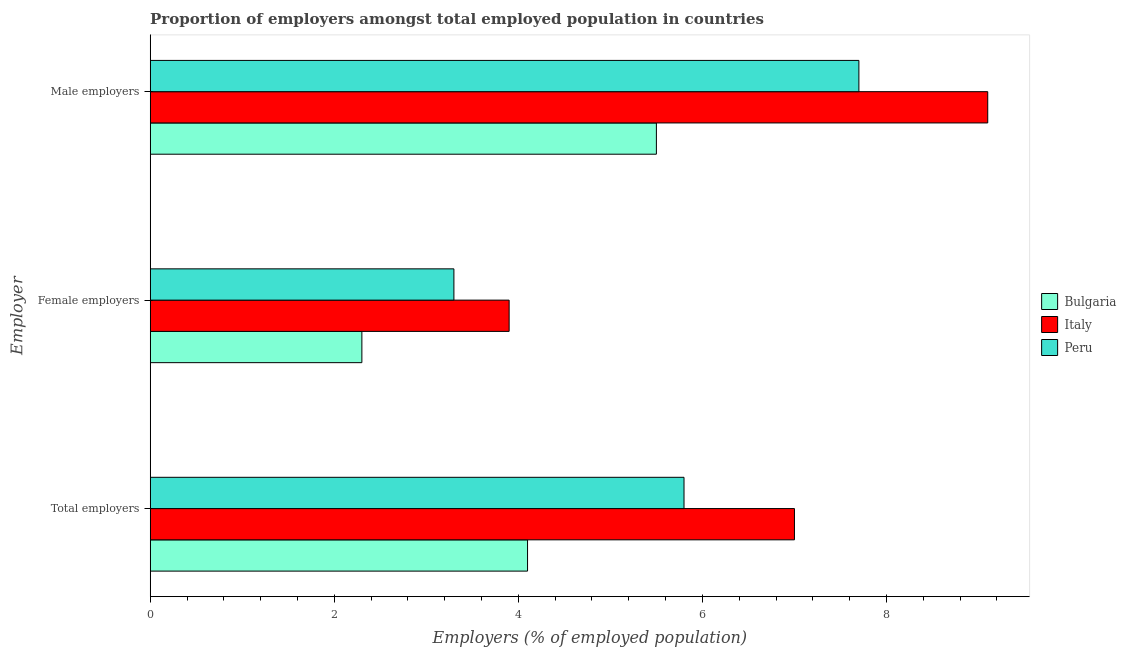Are the number of bars per tick equal to the number of legend labels?
Provide a short and direct response. Yes. Are the number of bars on each tick of the Y-axis equal?
Provide a succinct answer. Yes. What is the label of the 2nd group of bars from the top?
Your answer should be very brief. Female employers. What is the percentage of total employers in Bulgaria?
Offer a terse response. 4.1. Across all countries, what is the maximum percentage of total employers?
Provide a short and direct response. 7. Across all countries, what is the minimum percentage of total employers?
Keep it short and to the point. 4.1. In which country was the percentage of male employers maximum?
Make the answer very short. Italy. What is the total percentage of female employers in the graph?
Make the answer very short. 9.5. What is the difference between the percentage of female employers in Italy and that in Peru?
Keep it short and to the point. 0.6. What is the difference between the percentage of female employers in Bulgaria and the percentage of total employers in Peru?
Offer a very short reply. -3.5. What is the average percentage of male employers per country?
Provide a short and direct response. 7.43. What is the difference between the percentage of total employers and percentage of female employers in Italy?
Give a very brief answer. 3.1. In how many countries, is the percentage of male employers greater than 1.2000000000000002 %?
Provide a succinct answer. 3. What is the ratio of the percentage of female employers in Bulgaria to that in Peru?
Provide a succinct answer. 0.7. What is the difference between the highest and the second highest percentage of total employers?
Your answer should be compact. 1.2. What is the difference between the highest and the lowest percentage of total employers?
Make the answer very short. 2.9. In how many countries, is the percentage of total employers greater than the average percentage of total employers taken over all countries?
Keep it short and to the point. 2. What does the 3rd bar from the bottom in Total employers represents?
Provide a short and direct response. Peru. Are all the bars in the graph horizontal?
Your response must be concise. Yes. How many countries are there in the graph?
Your answer should be very brief. 3. What is the title of the graph?
Offer a very short reply. Proportion of employers amongst total employed population in countries. Does "Bosnia and Herzegovina" appear as one of the legend labels in the graph?
Offer a terse response. No. What is the label or title of the X-axis?
Make the answer very short. Employers (% of employed population). What is the label or title of the Y-axis?
Keep it short and to the point. Employer. What is the Employers (% of employed population) in Bulgaria in Total employers?
Give a very brief answer. 4.1. What is the Employers (% of employed population) of Peru in Total employers?
Your answer should be very brief. 5.8. What is the Employers (% of employed population) of Bulgaria in Female employers?
Ensure brevity in your answer.  2.3. What is the Employers (% of employed population) in Italy in Female employers?
Offer a terse response. 3.9. What is the Employers (% of employed population) in Peru in Female employers?
Your answer should be very brief. 3.3. What is the Employers (% of employed population) in Italy in Male employers?
Offer a very short reply. 9.1. What is the Employers (% of employed population) in Peru in Male employers?
Provide a short and direct response. 7.7. Across all Employer, what is the maximum Employers (% of employed population) of Bulgaria?
Ensure brevity in your answer.  5.5. Across all Employer, what is the maximum Employers (% of employed population) of Italy?
Provide a succinct answer. 9.1. Across all Employer, what is the maximum Employers (% of employed population) of Peru?
Provide a short and direct response. 7.7. Across all Employer, what is the minimum Employers (% of employed population) in Bulgaria?
Your answer should be compact. 2.3. Across all Employer, what is the minimum Employers (% of employed population) of Italy?
Your response must be concise. 3.9. Across all Employer, what is the minimum Employers (% of employed population) in Peru?
Ensure brevity in your answer.  3.3. What is the total Employers (% of employed population) in Peru in the graph?
Make the answer very short. 16.8. What is the difference between the Employers (% of employed population) of Bulgaria in Total employers and that in Female employers?
Offer a terse response. 1.8. What is the difference between the Employers (% of employed population) of Peru in Total employers and that in Male employers?
Make the answer very short. -1.9. What is the difference between the Employers (% of employed population) in Peru in Female employers and that in Male employers?
Keep it short and to the point. -4.4. What is the difference between the Employers (% of employed population) of Italy in Total employers and the Employers (% of employed population) of Peru in Female employers?
Provide a short and direct response. 3.7. What is the difference between the Employers (% of employed population) of Bulgaria in Total employers and the Employers (% of employed population) of Italy in Male employers?
Ensure brevity in your answer.  -5. What is the difference between the Employers (% of employed population) of Italy in Total employers and the Employers (% of employed population) of Peru in Male employers?
Make the answer very short. -0.7. What is the difference between the Employers (% of employed population) in Bulgaria in Female employers and the Employers (% of employed population) in Italy in Male employers?
Give a very brief answer. -6.8. What is the difference between the Employers (% of employed population) of Bulgaria in Female employers and the Employers (% of employed population) of Peru in Male employers?
Offer a terse response. -5.4. What is the average Employers (% of employed population) in Bulgaria per Employer?
Provide a succinct answer. 3.97. What is the average Employers (% of employed population) of Italy per Employer?
Your answer should be very brief. 6.67. What is the difference between the Employers (% of employed population) in Bulgaria and Employers (% of employed population) in Peru in Female employers?
Provide a short and direct response. -1. What is the difference between the Employers (% of employed population) in Bulgaria and Employers (% of employed population) in Italy in Male employers?
Offer a very short reply. -3.6. What is the difference between the Employers (% of employed population) in Bulgaria and Employers (% of employed population) in Peru in Male employers?
Keep it short and to the point. -2.2. What is the difference between the Employers (% of employed population) of Italy and Employers (% of employed population) of Peru in Male employers?
Ensure brevity in your answer.  1.4. What is the ratio of the Employers (% of employed population) in Bulgaria in Total employers to that in Female employers?
Provide a short and direct response. 1.78. What is the ratio of the Employers (% of employed population) of Italy in Total employers to that in Female employers?
Offer a very short reply. 1.79. What is the ratio of the Employers (% of employed population) in Peru in Total employers to that in Female employers?
Make the answer very short. 1.76. What is the ratio of the Employers (% of employed population) of Bulgaria in Total employers to that in Male employers?
Offer a very short reply. 0.75. What is the ratio of the Employers (% of employed population) of Italy in Total employers to that in Male employers?
Make the answer very short. 0.77. What is the ratio of the Employers (% of employed population) in Peru in Total employers to that in Male employers?
Give a very brief answer. 0.75. What is the ratio of the Employers (% of employed population) of Bulgaria in Female employers to that in Male employers?
Your response must be concise. 0.42. What is the ratio of the Employers (% of employed population) of Italy in Female employers to that in Male employers?
Give a very brief answer. 0.43. What is the ratio of the Employers (% of employed population) of Peru in Female employers to that in Male employers?
Make the answer very short. 0.43. What is the difference between the highest and the second highest Employers (% of employed population) in Italy?
Give a very brief answer. 2.1. What is the difference between the highest and the lowest Employers (% of employed population) of Bulgaria?
Make the answer very short. 3.2. What is the difference between the highest and the lowest Employers (% of employed population) in Italy?
Your answer should be very brief. 5.2. What is the difference between the highest and the lowest Employers (% of employed population) of Peru?
Provide a succinct answer. 4.4. 